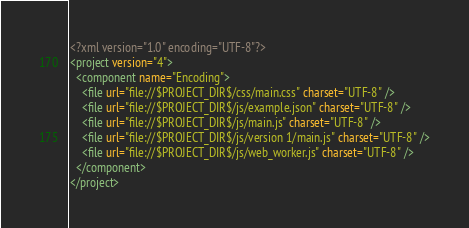<code> <loc_0><loc_0><loc_500><loc_500><_XML_><?xml version="1.0" encoding="UTF-8"?>
<project version="4">
  <component name="Encoding">
    <file url="file://$PROJECT_DIR$/css/main.css" charset="UTF-8" />
    <file url="file://$PROJECT_DIR$/js/example.json" charset="UTF-8" />
    <file url="file://$PROJECT_DIR$/js/main.js" charset="UTF-8" />
    <file url="file://$PROJECT_DIR$/js/version 1/main.js" charset="UTF-8" />
    <file url="file://$PROJECT_DIR$/js/web_worker.js" charset="UTF-8" />
  </component>
</project></code> 